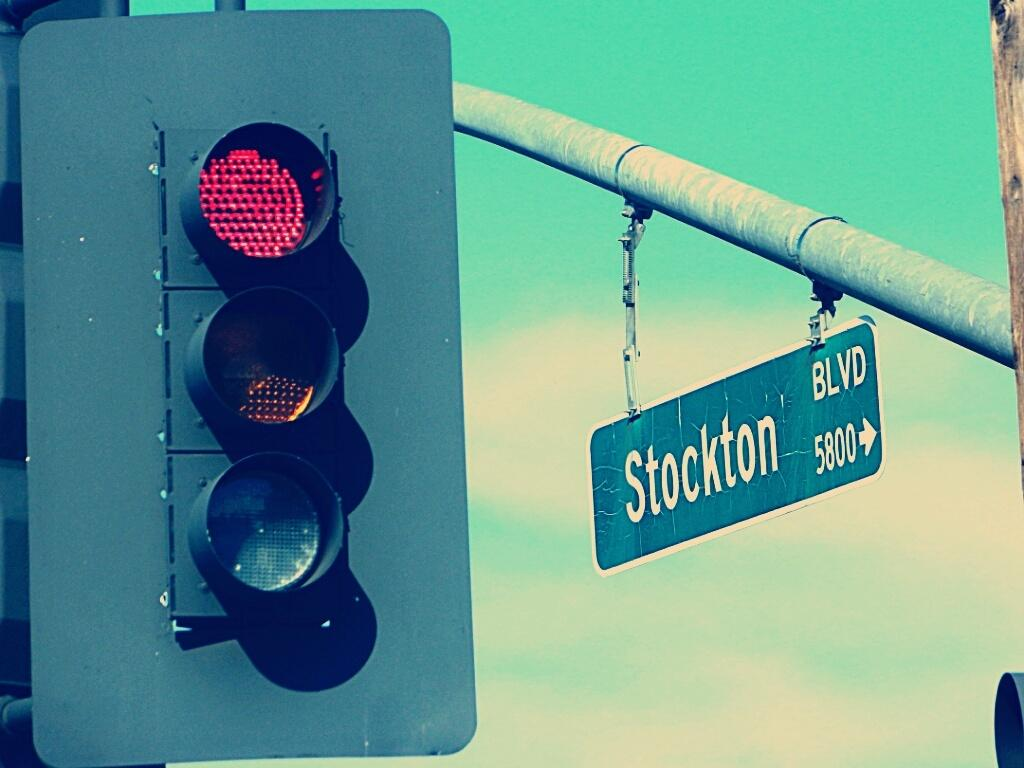Provide a one-sentence caption for the provided image. A street sign for Stockton Blvd. hangs near a traffic signal. 